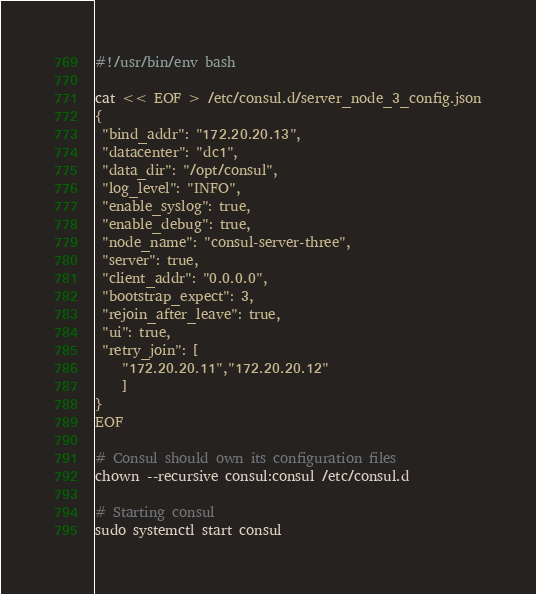Convert code to text. <code><loc_0><loc_0><loc_500><loc_500><_Bash_>#!/usr/bin/env bash

cat << EOF > /etc/consul.d/server_node_3_config.json
{
 "bind_addr": "172.20.20.13",
 "datacenter": "dc1",
 "data_dir": "/opt/consul",
 "log_level": "INFO",
 "enable_syslog": true,
 "enable_debug": true,
 "node_name": "consul-server-three",
 "server": true,
 "client_addr": "0.0.0.0",
 "bootstrap_expect": 3,
 "rejoin_after_leave": true,
 "ui": true,
 "retry_join": [
    "172.20.20.11","172.20.20.12"
    ]
}
EOF

# Consul should own its configuration files
chown --recursive consul:consul /etc/consul.d

# Starting consul
sudo systemctl start consul</code> 